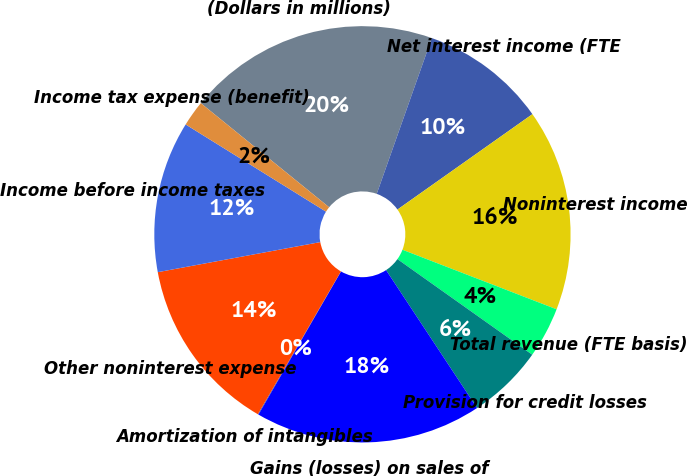Convert chart. <chart><loc_0><loc_0><loc_500><loc_500><pie_chart><fcel>(Dollars in millions)<fcel>Net interest income (FTE<fcel>Noninterest income<fcel>Total revenue (FTE basis)<fcel>Provision for credit losses<fcel>Gains (losses) on sales of<fcel>Amortization of intangibles<fcel>Other noninterest expense<fcel>Income before income taxes<fcel>Income tax expense (benefit)<nl><fcel>19.56%<fcel>9.8%<fcel>15.66%<fcel>3.95%<fcel>5.9%<fcel>17.61%<fcel>0.05%<fcel>13.71%<fcel>11.76%<fcel>2.0%<nl></chart> 